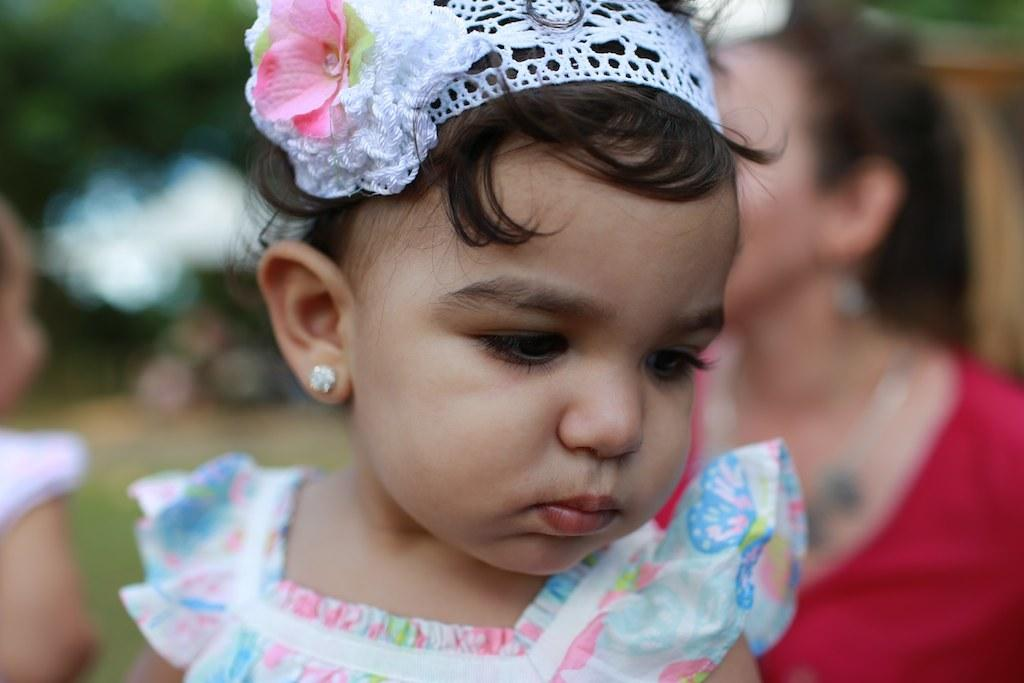What is the main subject in the foreground of the image? There is a baby girl in the foreground of the image. How is the background of the image depicted? The background of the girl is blurred. What type of gold jewelry is the baby girl wearing in the image? There is no mention of gold jewelry or any jewelry in the image, so it cannot be determined from the image. 